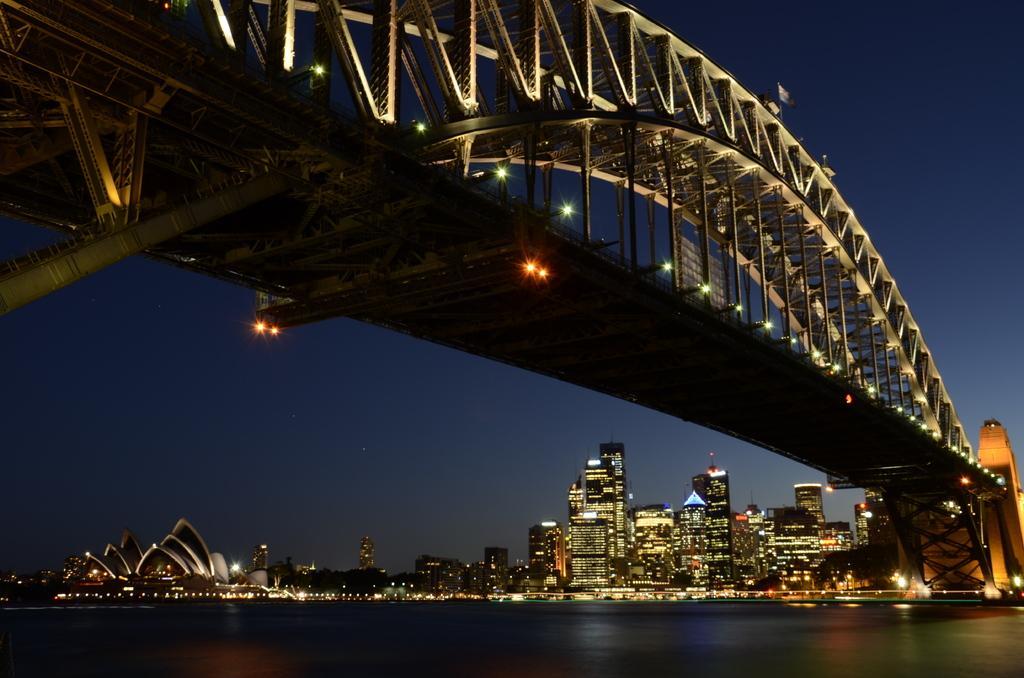How would you summarize this image in a sentence or two? In this picture I can see at the bottom there is water, in the middle there are buildings with lights, at the top there is a bridge and the sky. 